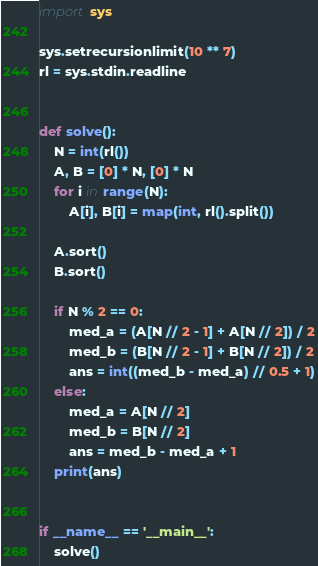Convert code to text. <code><loc_0><loc_0><loc_500><loc_500><_Python_>import sys

sys.setrecursionlimit(10 ** 7)
rl = sys.stdin.readline


def solve():
    N = int(rl())
    A, B = [0] * N, [0] * N
    for i in range(N):
        A[i], B[i] = map(int, rl().split())
    
    A.sort()
    B.sort()
    
    if N % 2 == 0:
        med_a = (A[N // 2 - 1] + A[N // 2]) / 2
        med_b = (B[N // 2 - 1] + B[N // 2]) / 2
        ans = int((med_b - med_a) // 0.5 + 1)
    else:
        med_a = A[N // 2]
        med_b = B[N // 2]
        ans = med_b - med_a + 1
    print(ans)


if __name__ == '__main__':
    solve()
</code> 